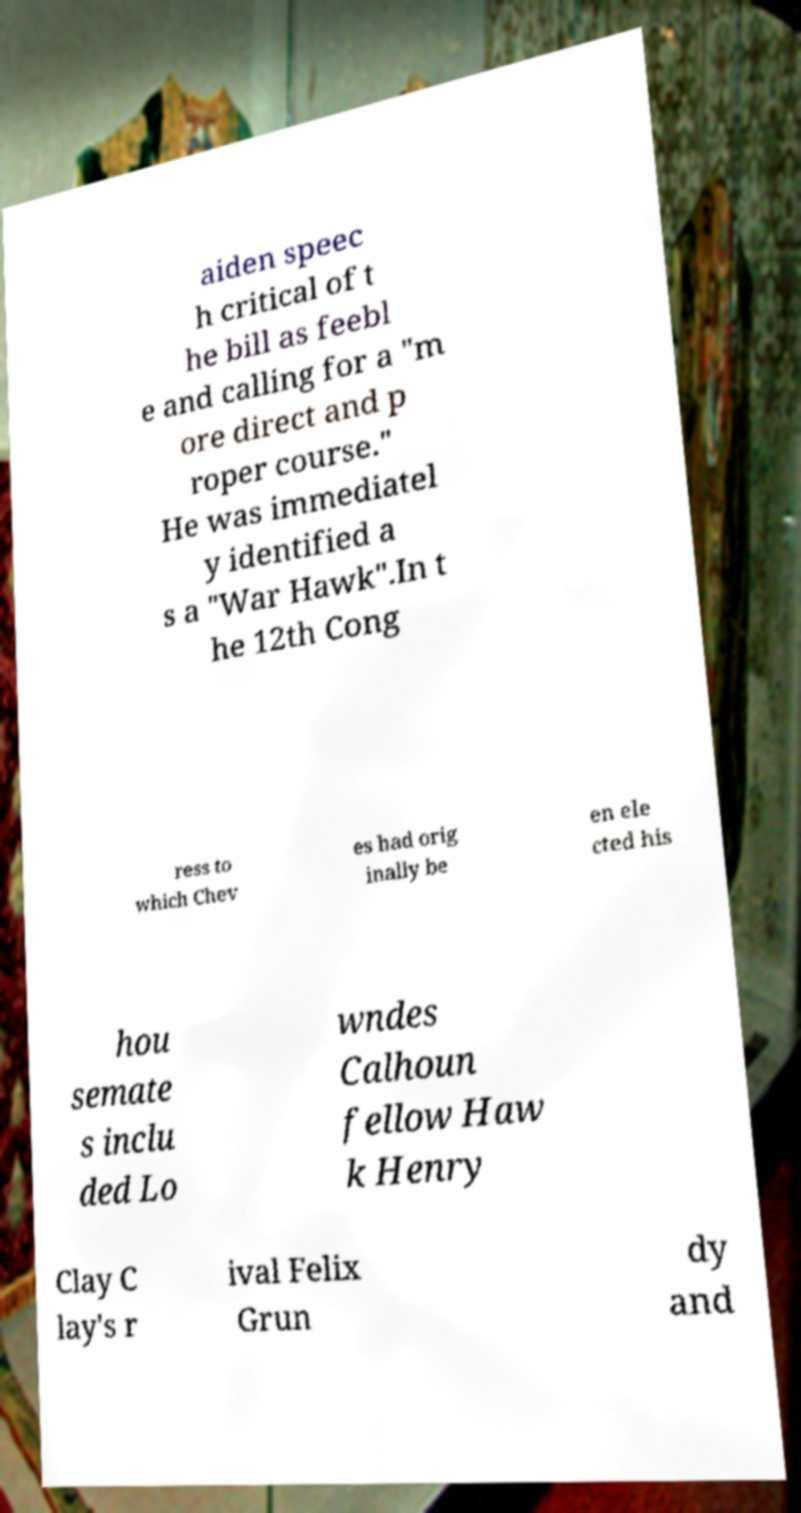There's text embedded in this image that I need extracted. Can you transcribe it verbatim? aiden speec h critical of t he bill as feebl e and calling for a "m ore direct and p roper course." He was immediatel y identified a s a "War Hawk".In t he 12th Cong ress to which Chev es had orig inally be en ele cted his hou semate s inclu ded Lo wndes Calhoun fellow Haw k Henry Clay C lay's r ival Felix Grun dy and 